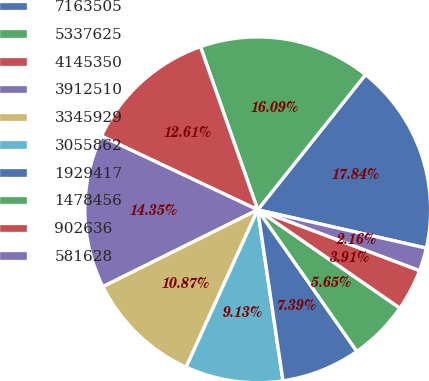<chart> <loc_0><loc_0><loc_500><loc_500><pie_chart><fcel>7163505<fcel>5337625<fcel>4145350<fcel>3912510<fcel>3345929<fcel>3055862<fcel>1929417<fcel>1478456<fcel>902636<fcel>581628<nl><fcel>17.84%<fcel>16.09%<fcel>12.61%<fcel>14.35%<fcel>10.87%<fcel>9.13%<fcel>7.39%<fcel>5.65%<fcel>3.91%<fcel>2.16%<nl></chart> 